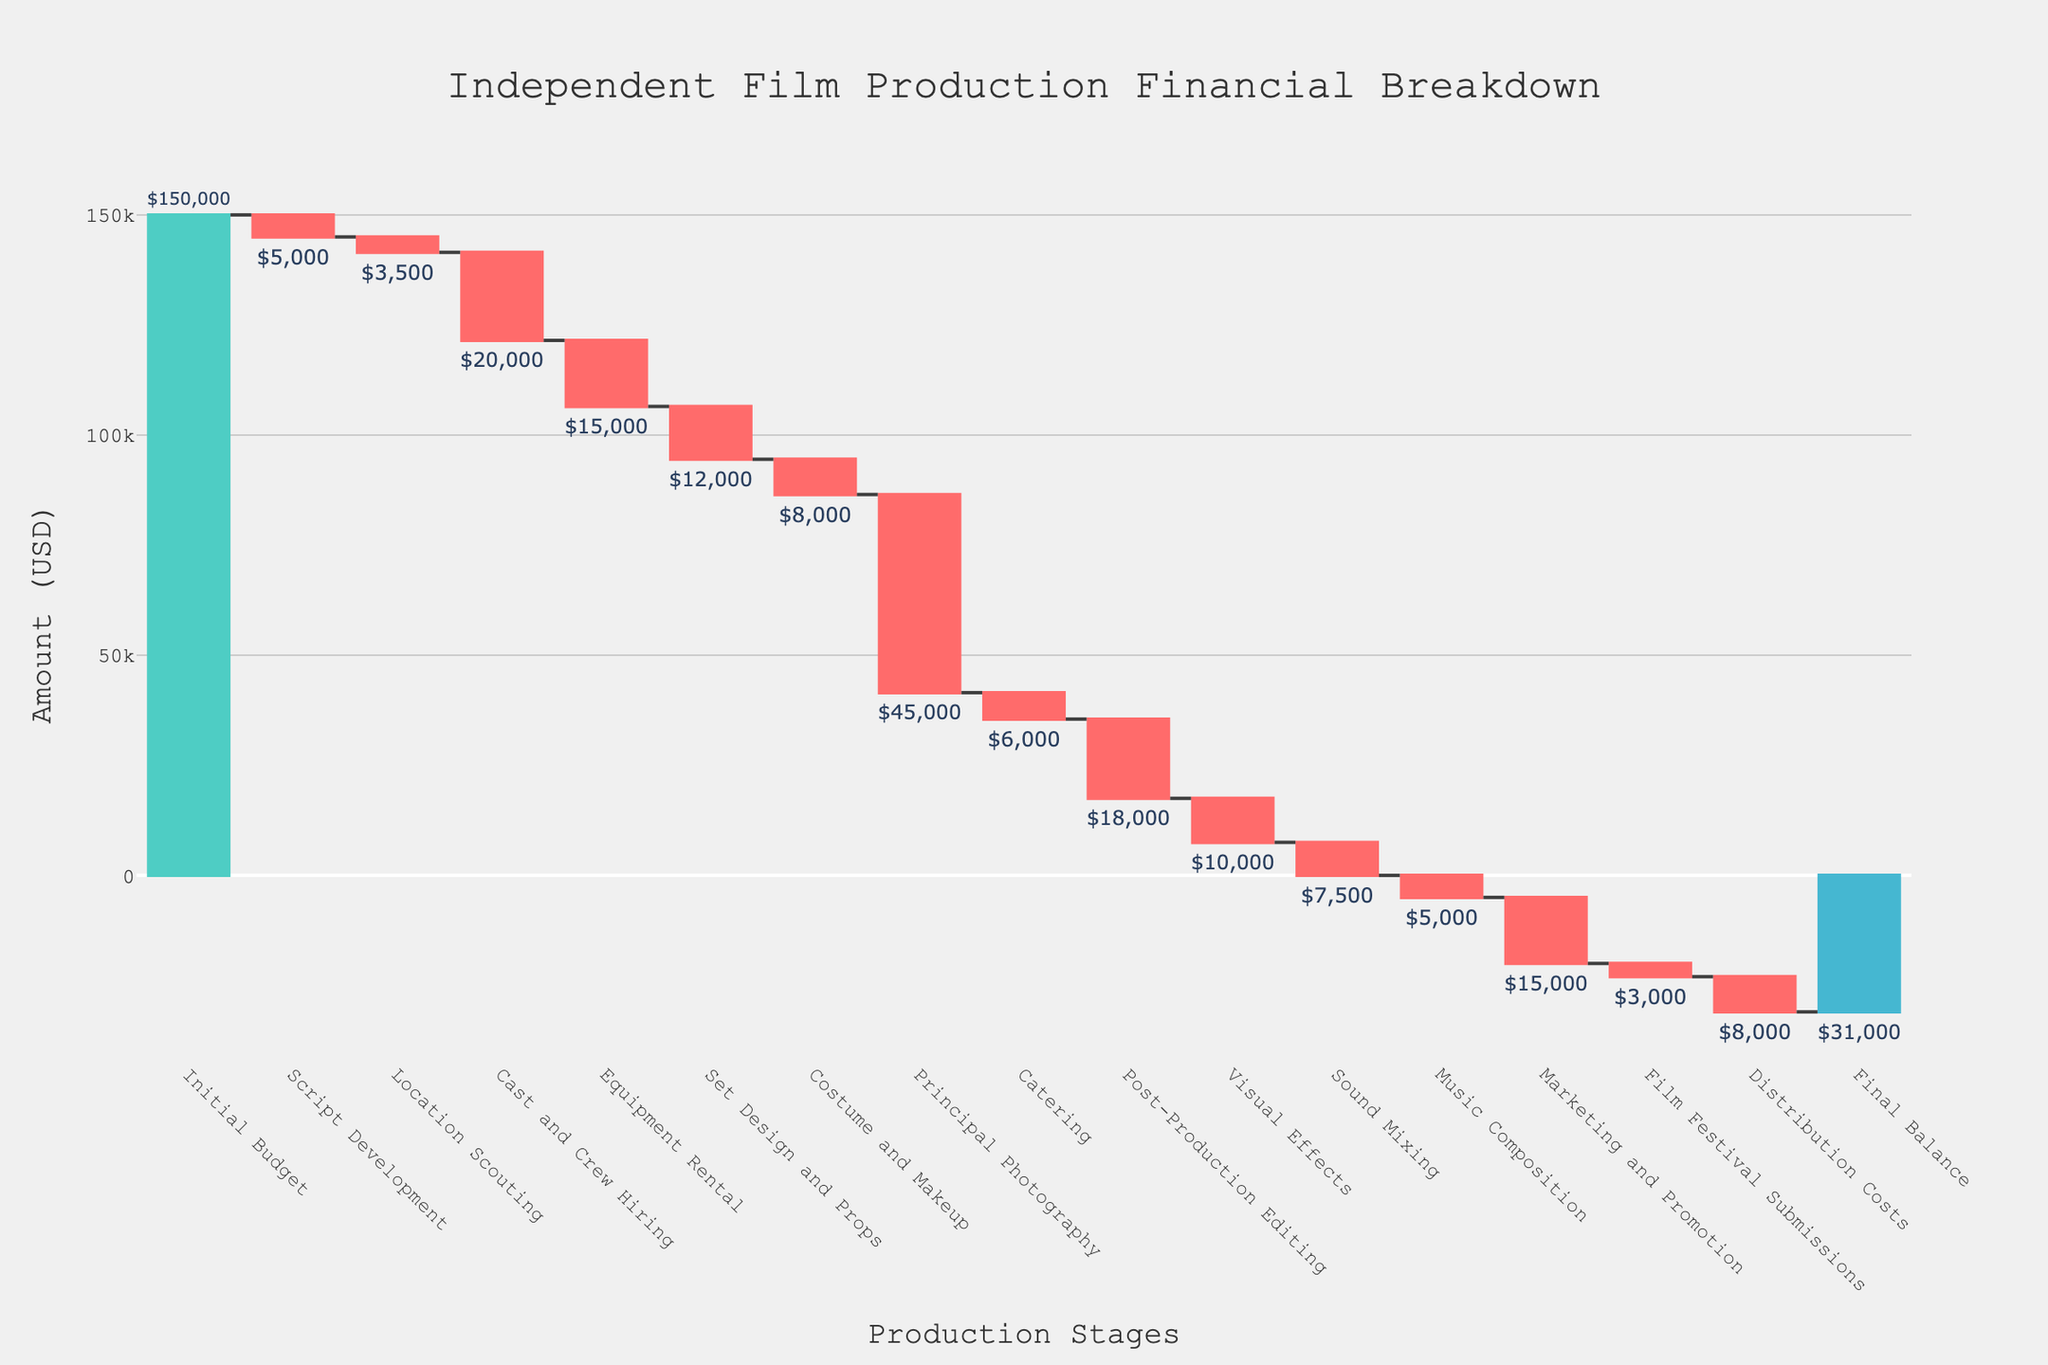What is the title of the chart? The title is found at the top center of the chart, representing the overall subject it covers. The title reads "Independent Film Production Financial Breakdown."
Answer: Independent Film Production Financial Breakdown Which category has the highest expense in the production process? Observe the lengths and colors of the bars to determine the one with the largest negative value. The "Principal Photography" bar is the longest and most pronounced red bar.
Answer: Principal Photography What is the final balance at the end of the financial breakdown? Locate the final bar on the right, which shows the cumulative total, marked as "Final Balance" with the value below the bar. The value shown is -$31,000.
Answer: -$31,000 How much was initially budgeted for the film production? Check the first bar on the left labeled "Initial Budget" and note its value. The initial budget value is $150,000.
Answer: $150,000 What are the total costs incurred from "Post-Production Editing," "Visual Effects," and "Sound Mixing"? Add the values for the three categories: Post-Production Editing (-$18,000), Visual Effects (-$10,000), and Sound Mixing (-$7,500). The sum is -$18,000 + -$10,000 + -$7,500.
Answer: -$35,500 Which category has the smallest expense and what is its value? Look through the negative bars for the one with the smallest value. The "Film Festival Submissions" bar is the shortest red bar, valued at -$3,000.
Answer: Film Festival Submissions, -$3,000 How much was spent on "Script Development" compared to "Music Composition"? Compare the two bars by looking at their respective values: Script Development (-$5,000) and Music Composition (-$5,000).
Answer: Equal What amount was spent during the pre-production phase (Script Development, Location Scouting, Cast and Crew Hiring)? Sum the expenditures: Script Development (-$5,000), Location Scouting (-$3,500), and Cast and Crew Hiring (-$20,000). Total is -$5,000 + -$3,500 + -$20,000.
Answer: -$28,500 Which phase had more expenditure: "Post-Production Editing" or "Marketing and Promotion"? Compare the bars for the two categories. Post-Production Editing shows -$18,000, and Marketing and Promotion shows -$15,000, resulting in more expenses in Post-Production Editing.
Answer: Post-Production Editing 